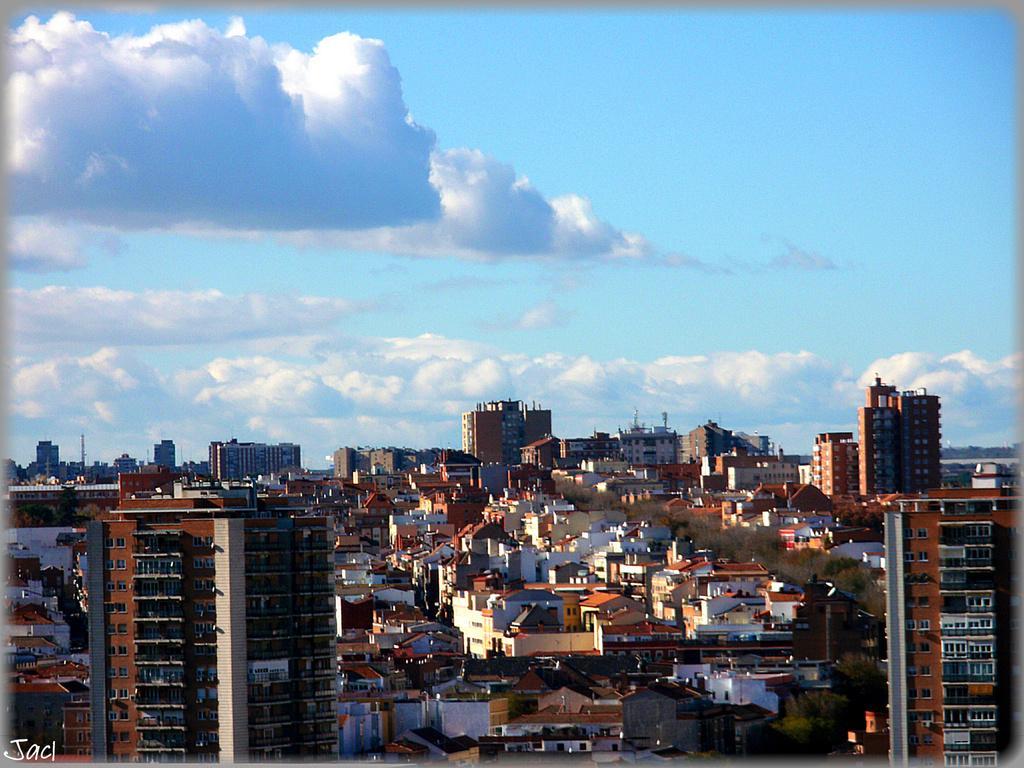How would you summarize this image in a sentence or two? In this image I can see number of buildings, trees and in the background I can see clouds and the sky. Here I can see watermark. 